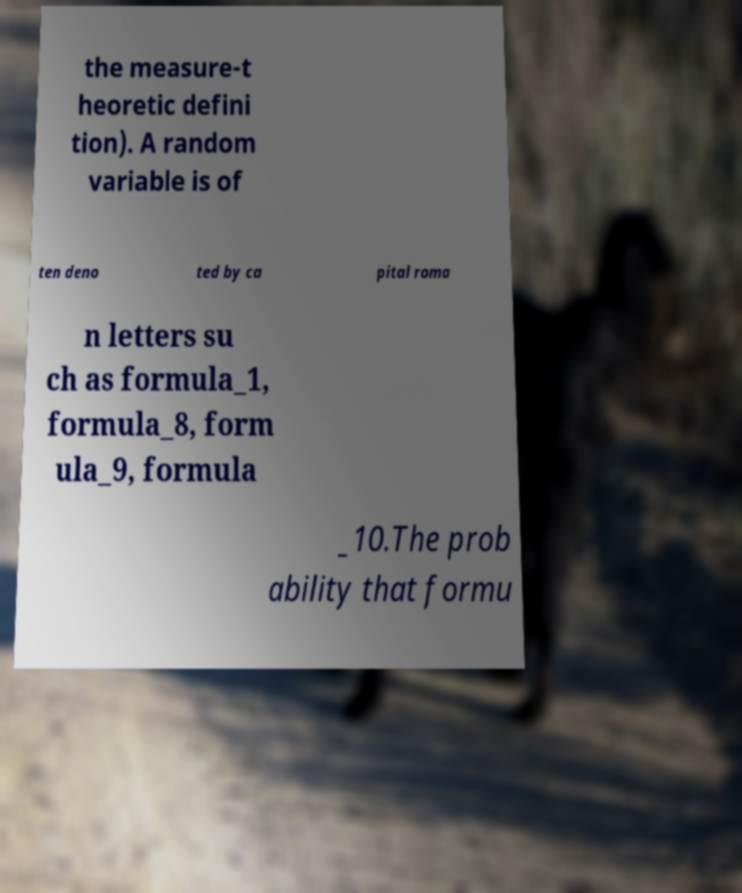Please read and relay the text visible in this image. What does it say? the measure-t heoretic defini tion). A random variable is of ten deno ted by ca pital roma n letters su ch as formula_1, formula_8, form ula_9, formula _10.The prob ability that formu 